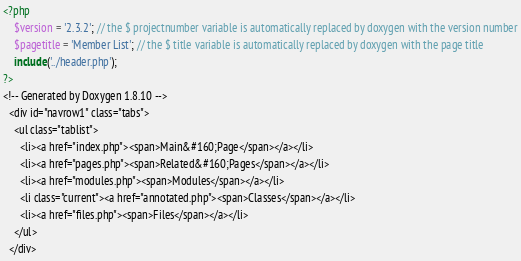Convert code to text. <code><loc_0><loc_0><loc_500><loc_500><_PHP_><?php
    $version = '2.3.2'; // the $ projectnumber variable is automatically replaced by doxygen with the version number
    $pagetitle = 'Member List'; // the $ title variable is automatically replaced by doxygen with the page title
    include('../header.php');
?>
<!-- Generated by Doxygen 1.8.10 -->
  <div id="navrow1" class="tabs">
    <ul class="tablist">
      <li><a href="index.php"><span>Main&#160;Page</span></a></li>
      <li><a href="pages.php"><span>Related&#160;Pages</span></a></li>
      <li><a href="modules.php"><span>Modules</span></a></li>
      <li class="current"><a href="annotated.php"><span>Classes</span></a></li>
      <li><a href="files.php"><span>Files</span></a></li>
    </ul>
  </div></code> 